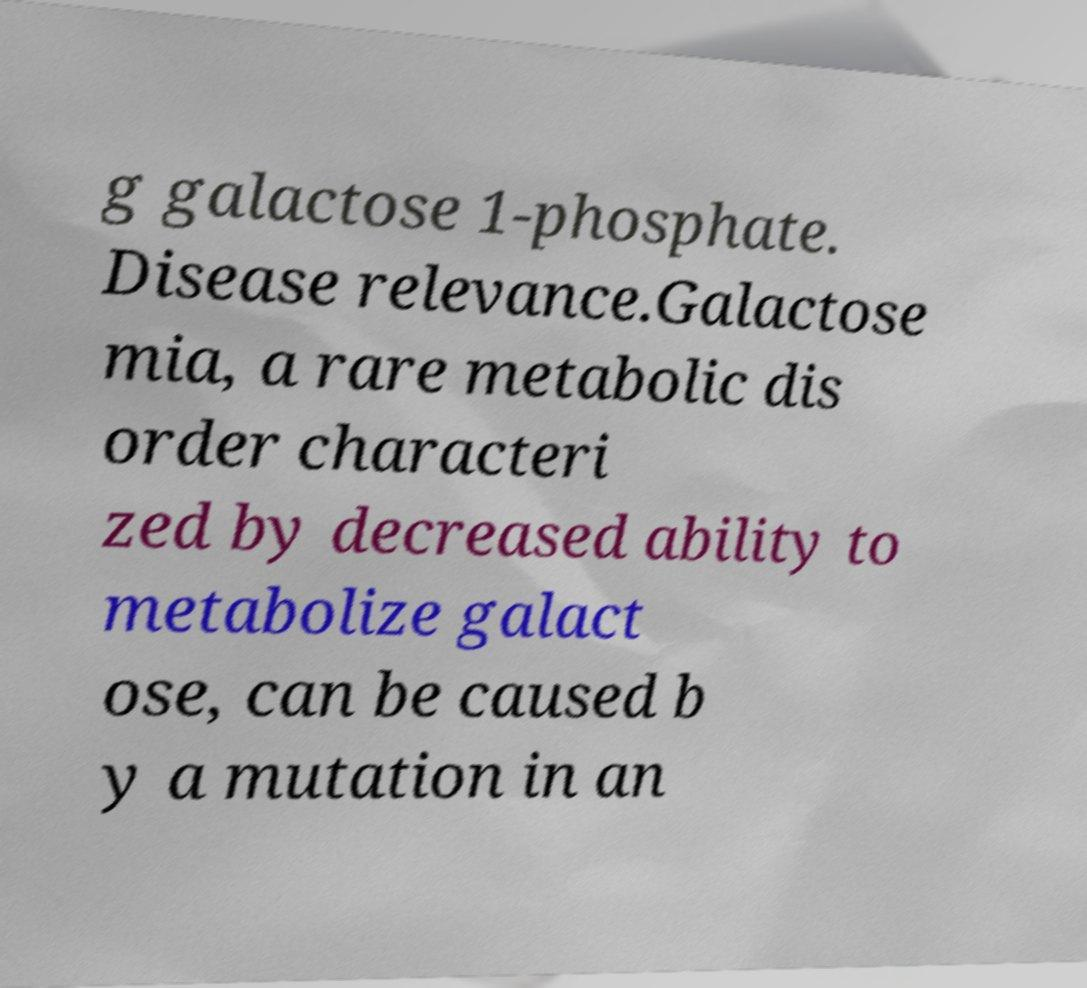I need the written content from this picture converted into text. Can you do that? g galactose 1-phosphate. Disease relevance.Galactose mia, a rare metabolic dis order characteri zed by decreased ability to metabolize galact ose, can be caused b y a mutation in an 